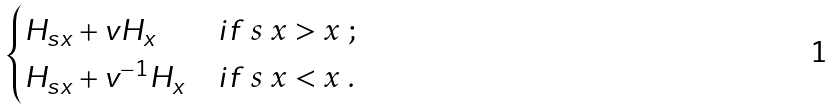Convert formula to latex. <formula><loc_0><loc_0><loc_500><loc_500>\begin{cases} H _ { s x } + v H _ { x } & i f $ s x > x $ ; \\ H _ { s x } + v ^ { - 1 } H _ { x } & i f $ s x < x $ . \end{cases}</formula> 